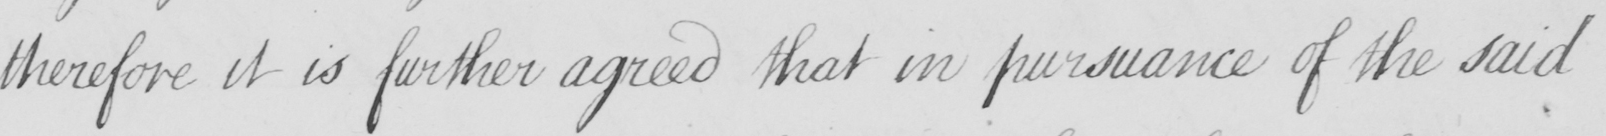What text is written in this handwritten line? therefore it is further agreed that in pursuance of the said 